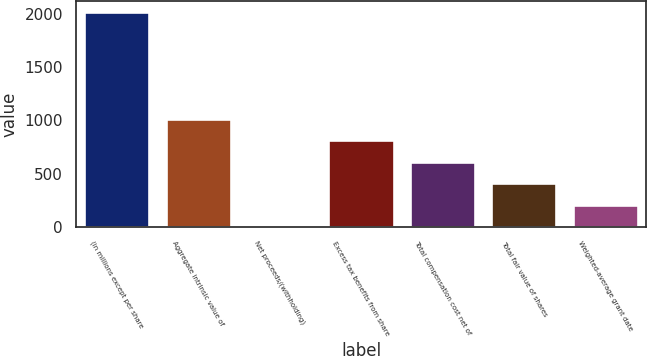Convert chart. <chart><loc_0><loc_0><loc_500><loc_500><bar_chart><fcel>(in millions except per share<fcel>Aggregate intrinsic value of<fcel>Net proceeds/(withholding)<fcel>Excess tax benefits from share<fcel>Total compensation cost net of<fcel>Total fair value of shares<fcel>Weighted-average grant date<nl><fcel>2016<fcel>1011<fcel>6<fcel>810<fcel>609<fcel>408<fcel>207<nl></chart> 